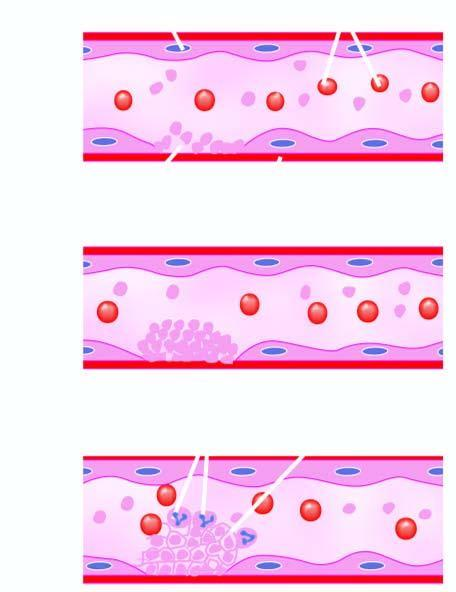s the alveolar capillaries released which causes further aggregation of platelets following platelet release reaction?
Answer the question using a single word or phrase. No 